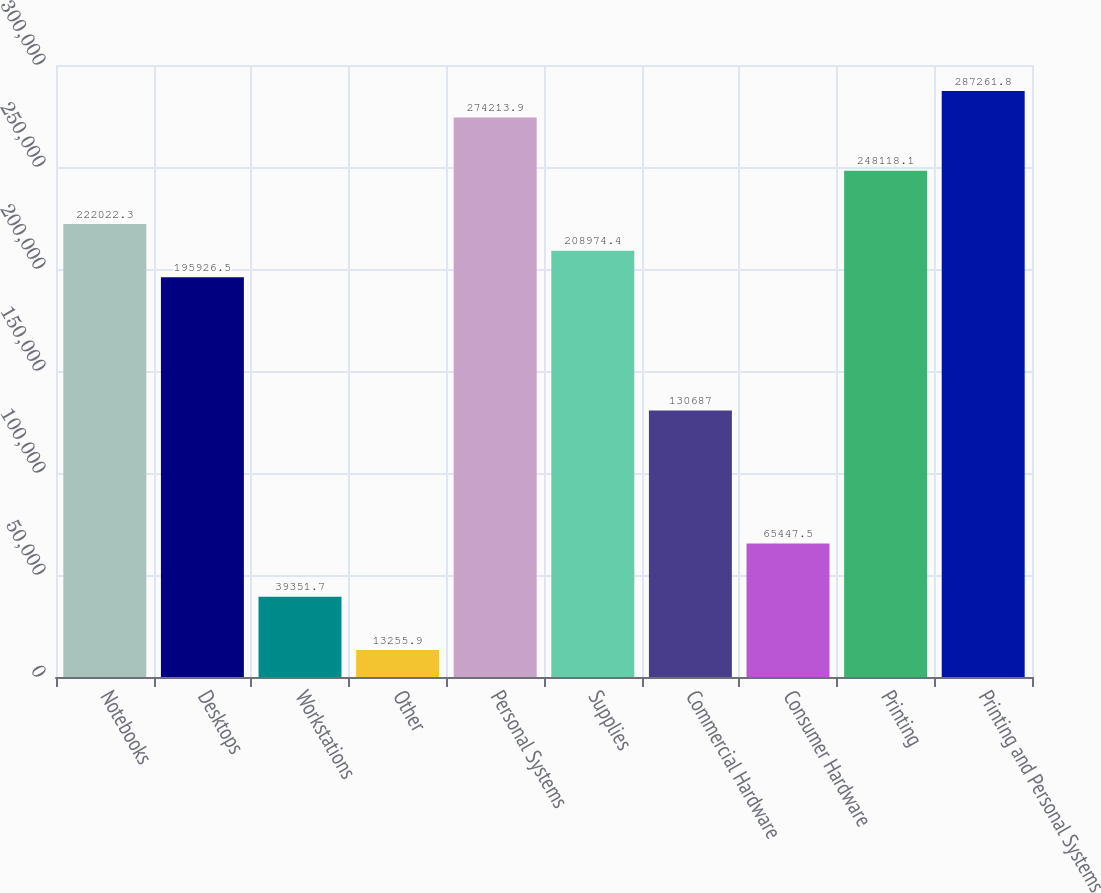Convert chart to OTSL. <chart><loc_0><loc_0><loc_500><loc_500><bar_chart><fcel>Notebooks<fcel>Desktops<fcel>Workstations<fcel>Other<fcel>Personal Systems<fcel>Supplies<fcel>Commercial Hardware<fcel>Consumer Hardware<fcel>Printing<fcel>Printing and Personal Systems<nl><fcel>222022<fcel>195926<fcel>39351.7<fcel>13255.9<fcel>274214<fcel>208974<fcel>130687<fcel>65447.5<fcel>248118<fcel>287262<nl></chart> 